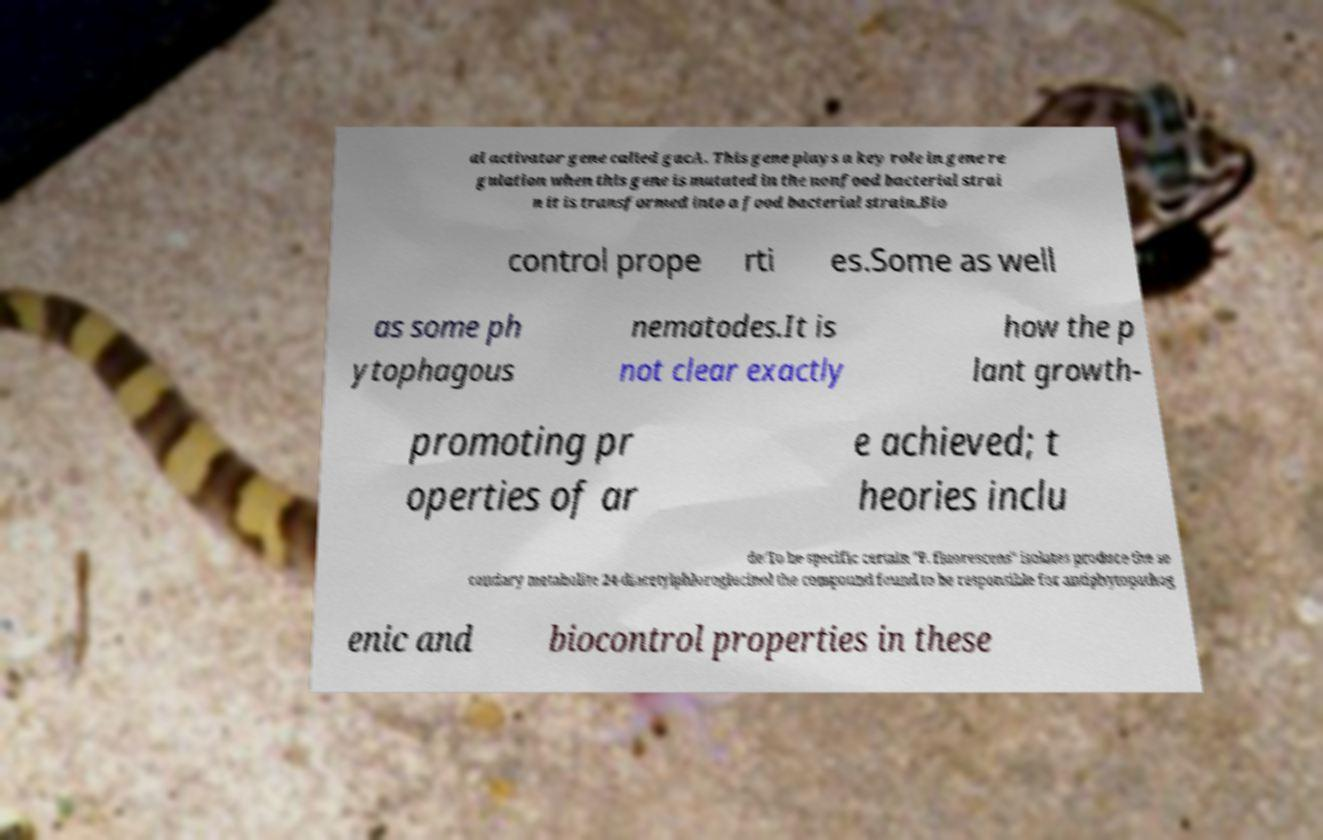There's text embedded in this image that I need extracted. Can you transcribe it verbatim? al activator gene called gacA. This gene plays a key role in gene re gulation when this gene is mutated in the nonfood bacterial strai n it is transformed into a food bacterial strain.Bio control prope rti es.Some as well as some ph ytophagous nematodes.It is not clear exactly how the p lant growth- promoting pr operties of ar e achieved; t heories inclu de:To be specific certain "P. fluorescens" isolates produce the se condary metabolite 24-diacetylphloroglucinol the compound found to be responsible for antiphytopathog enic and biocontrol properties in these 